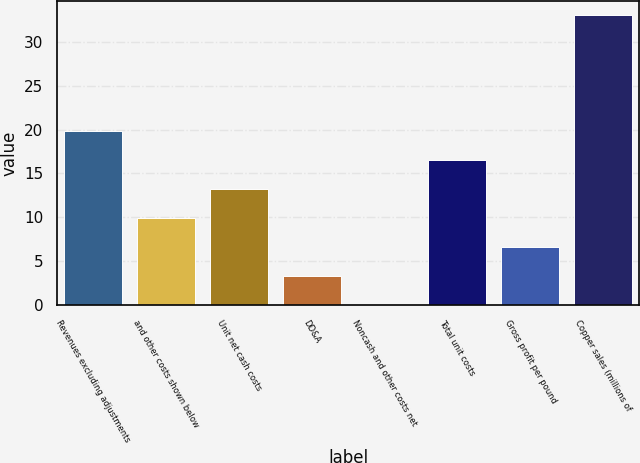Convert chart. <chart><loc_0><loc_0><loc_500><loc_500><bar_chart><fcel>Revenues excluding adjustments<fcel>and other costs shown below<fcel>Unit net cash costs<fcel>DD&A<fcel>Noncash and other costs net<fcel>Total unit costs<fcel>Gross profit per pound<fcel>Copper sales (millions of<nl><fcel>19.81<fcel>9.94<fcel>13.23<fcel>3.36<fcel>0.07<fcel>16.52<fcel>6.65<fcel>33<nl></chart> 